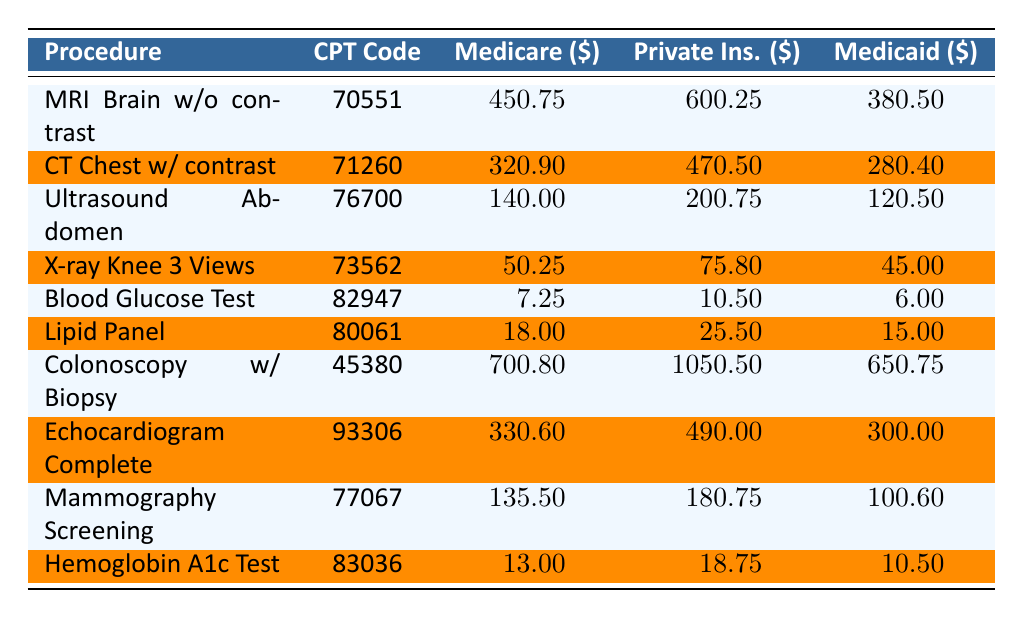What is the Medicare reimbursement rate for a Colonoscopy with Biopsy? The table lists the Medicare reimbursement rate for a Colonoscopy with Biopsy, which is stated in the column under "Medicare ($)". Looking at the relevant row for this procedure, the value is 700.80.
Answer: 700.80 What is the difference between the Private Insurance reimbursement average and the Medicare reimbursement rate for an Echocardiogram Complete? The Private Insurance reimbursement average for an Echocardiogram Complete is 490.00, and the Medicare reimbursement rate is 330.60. To find the difference, subtract the Medicare rate from the Private Insurance average: 490.00 - 330.60 = 159.40.
Answer: 159.40 Is the Medicaid reimbursement rate for a Blood Glucose Test higher than that for an Ultrasound Abdomen Complete? The Medicaid reimbursement rate for a Blood Glucose Test is 6.00, while for an Ultrasound Abdomen Complete it is 120.50. Since 6.00 is less than 120.50, the statement is false.
Answer: No What is the average reimbursement rate from Private Insurance for all the procedures listed? First, we identify the Private Insurance reimbursement rates for each procedure: 600.25, 470.50, 200.75, 75.80, 10.50, 25.50, 1050.50, 490.00, 180.75, 18.75. Next, we sum these values: 600.25 + 470.50 + 200.75 + 75.80 + 10.50 + 25.50 + 1050.50 + 490.00 + 180.75 + 18.75 = 3133.50. There are 10 procedures, so the average is 3133.50 / 10 = 313.35.
Answer: 313.35 Which procedure has the highest Medicaid reimbursement rate and what is that rate? The Medicaid reimbursement rates for all procedures need to be compared. The rates are: 380.50 (MRI Brain), 280.40 (CT Chest), 120.50 (Ultrasound), 45.00 (X-ray), 6.00 (Blood Glucose), 15.00 (Lipid Panel), 650.75 (Colonoscopy), 300.00 (Echocardiogram), 100.60 (Mammography), and 10.50 (Hemoglobin A1c). The highest among these is 650.75 for the Colonoscopy with Biopsy.
Answer: 650.75 Is there a procedure where the Medicare reimbursement rate is equal to or higher than the average of Private Insurance rebates? The averages for Private Insurance rebates can be calculated as before. The average is about 313.35. Now checking against each Medicare rate, MRI Brain (450.75), CT Chest (320.90), Colonoscopy (700.80), and Echocardiogram (330.60) are higher. Therefore, there are procedures with higher Medicare rates.
Answer: Yes 